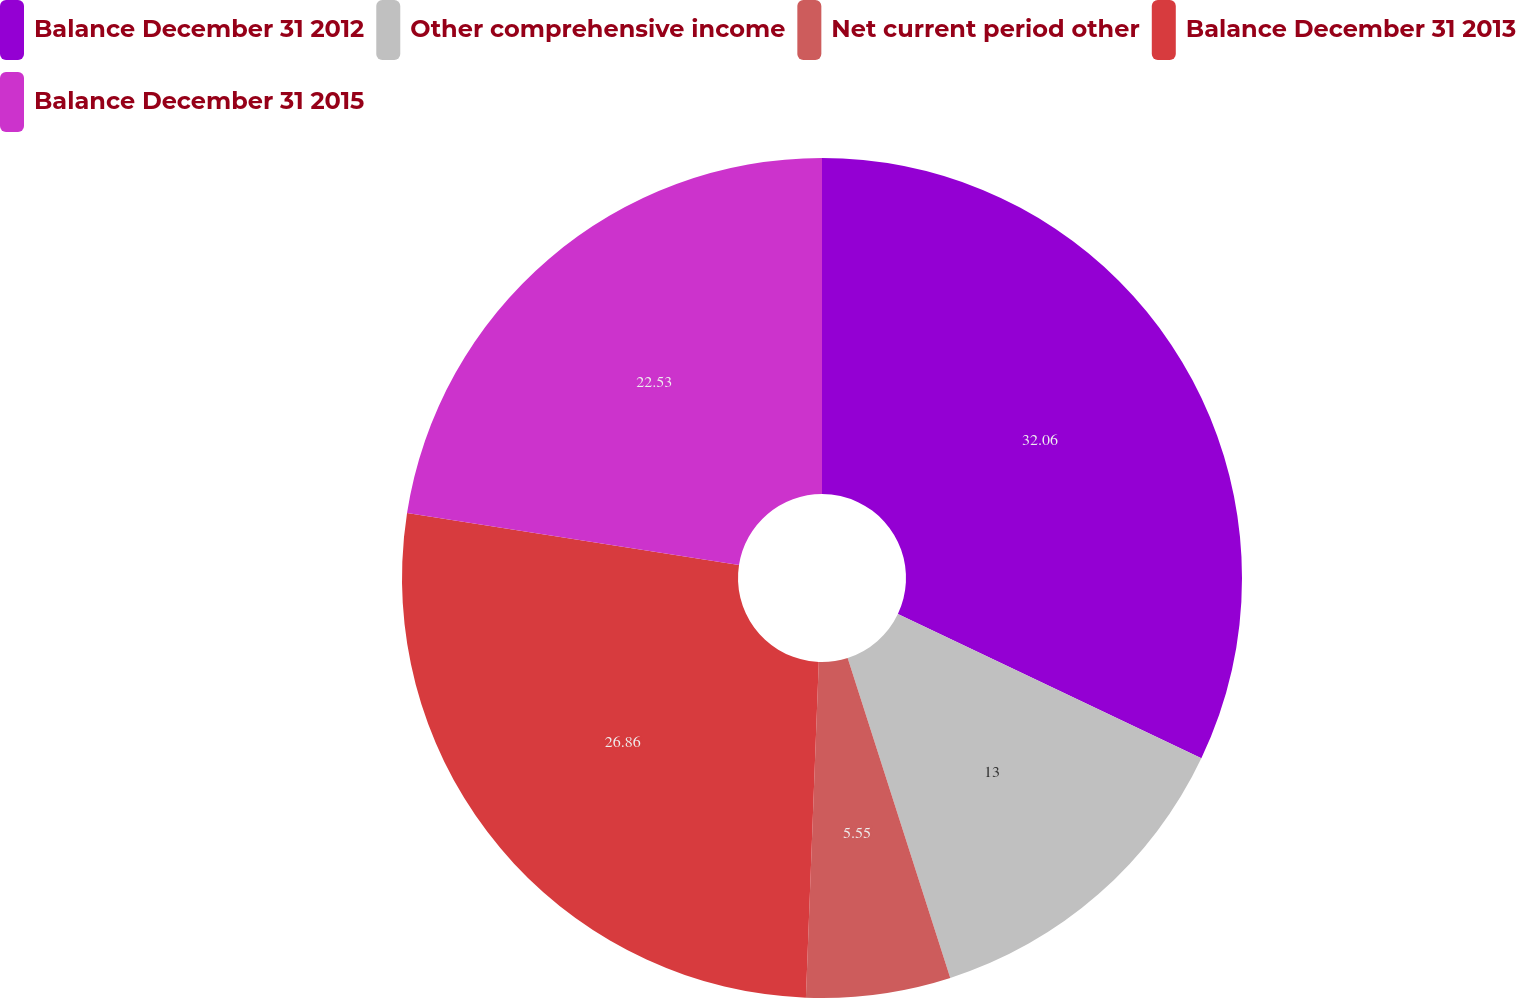Convert chart. <chart><loc_0><loc_0><loc_500><loc_500><pie_chart><fcel>Balance December 31 2012<fcel>Other comprehensive income<fcel>Net current period other<fcel>Balance December 31 2013<fcel>Balance December 31 2015<nl><fcel>32.06%<fcel>13.0%<fcel>5.55%<fcel>26.86%<fcel>22.53%<nl></chart> 